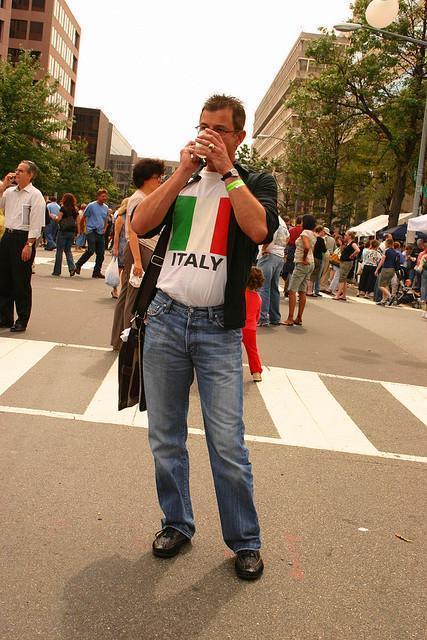How many handbags are in the picture?
Give a very brief answer. 1. How many people are there?
Give a very brief answer. 5. How many slices of pizza are there?
Give a very brief answer. 0. 